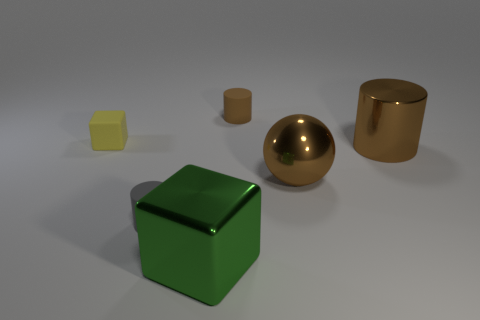Add 4 tiny gray rubber cylinders. How many objects exist? 10 Subtract all balls. How many objects are left? 5 Subtract all large yellow balls. Subtract all small objects. How many objects are left? 3 Add 6 metallic blocks. How many metallic blocks are left? 7 Add 1 small cyan shiny blocks. How many small cyan shiny blocks exist? 1 Subtract 0 red balls. How many objects are left? 6 